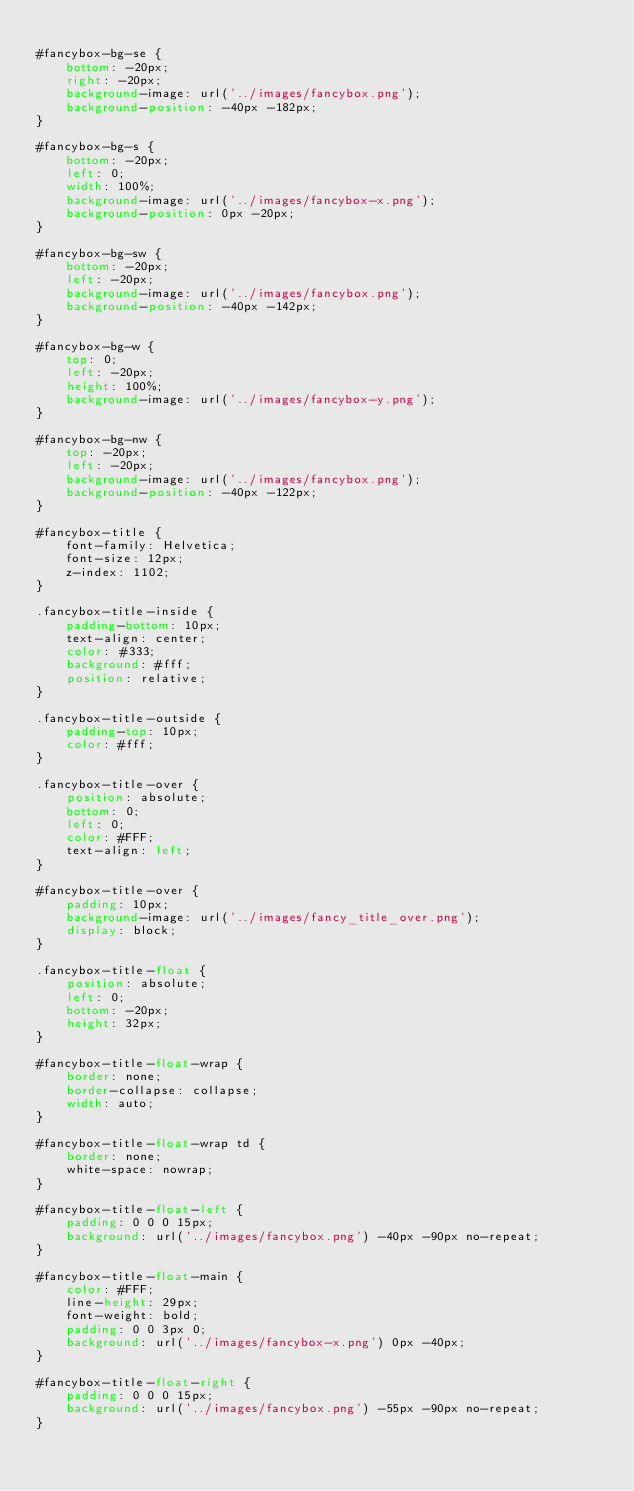<code> <loc_0><loc_0><loc_500><loc_500><_CSS_>
#fancybox-bg-se {
	bottom: -20px;
	right: -20px;
	background-image: url('../images/fancybox.png');
	background-position: -40px -182px; 
}

#fancybox-bg-s {
	bottom: -20px;
	left: 0;
	width: 100%;
	background-image: url('../images/fancybox-x.png');
	background-position: 0px -20px;
}

#fancybox-bg-sw {
	bottom: -20px;
	left: -20px;
	background-image: url('../images/fancybox.png');
	background-position: -40px -142px;
}

#fancybox-bg-w {
	top: 0;
	left: -20px;
	height: 100%;
	background-image: url('../images/fancybox-y.png');
}

#fancybox-bg-nw {
	top: -20px;
	left: -20px;
	background-image: url('../images/fancybox.png');
	background-position: -40px -122px;
}

#fancybox-title {
	font-family: Helvetica;
	font-size: 12px;
	z-index: 1102;
}

.fancybox-title-inside {
	padding-bottom: 10px;
	text-align: center;
	color: #333;
	background: #fff;
	position: relative;
}

.fancybox-title-outside {
	padding-top: 10px;
	color: #fff;
}

.fancybox-title-over {
	position: absolute;
	bottom: 0;
	left: 0;
	color: #FFF;
	text-align: left;
}

#fancybox-title-over {
	padding: 10px;
	background-image: url('../images/fancy_title_over.png');
	display: block;
}

.fancybox-title-float {
	position: absolute;
	left: 0;
	bottom: -20px;
	height: 32px;
}

#fancybox-title-float-wrap {
	border: none;
	border-collapse: collapse;
	width: auto;
}

#fancybox-title-float-wrap td {
	border: none;
	white-space: nowrap;
}

#fancybox-title-float-left {
	padding: 0 0 0 15px;
	background: url('../images/fancybox.png') -40px -90px no-repeat;
}

#fancybox-title-float-main {
	color: #FFF;
	line-height: 29px;
	font-weight: bold;
	padding: 0 0 3px 0;
	background: url('../images/fancybox-x.png') 0px -40px;
}

#fancybox-title-float-right {
	padding: 0 0 0 15px;
	background: url('../images/fancybox.png') -55px -90px no-repeat;
}
</code> 